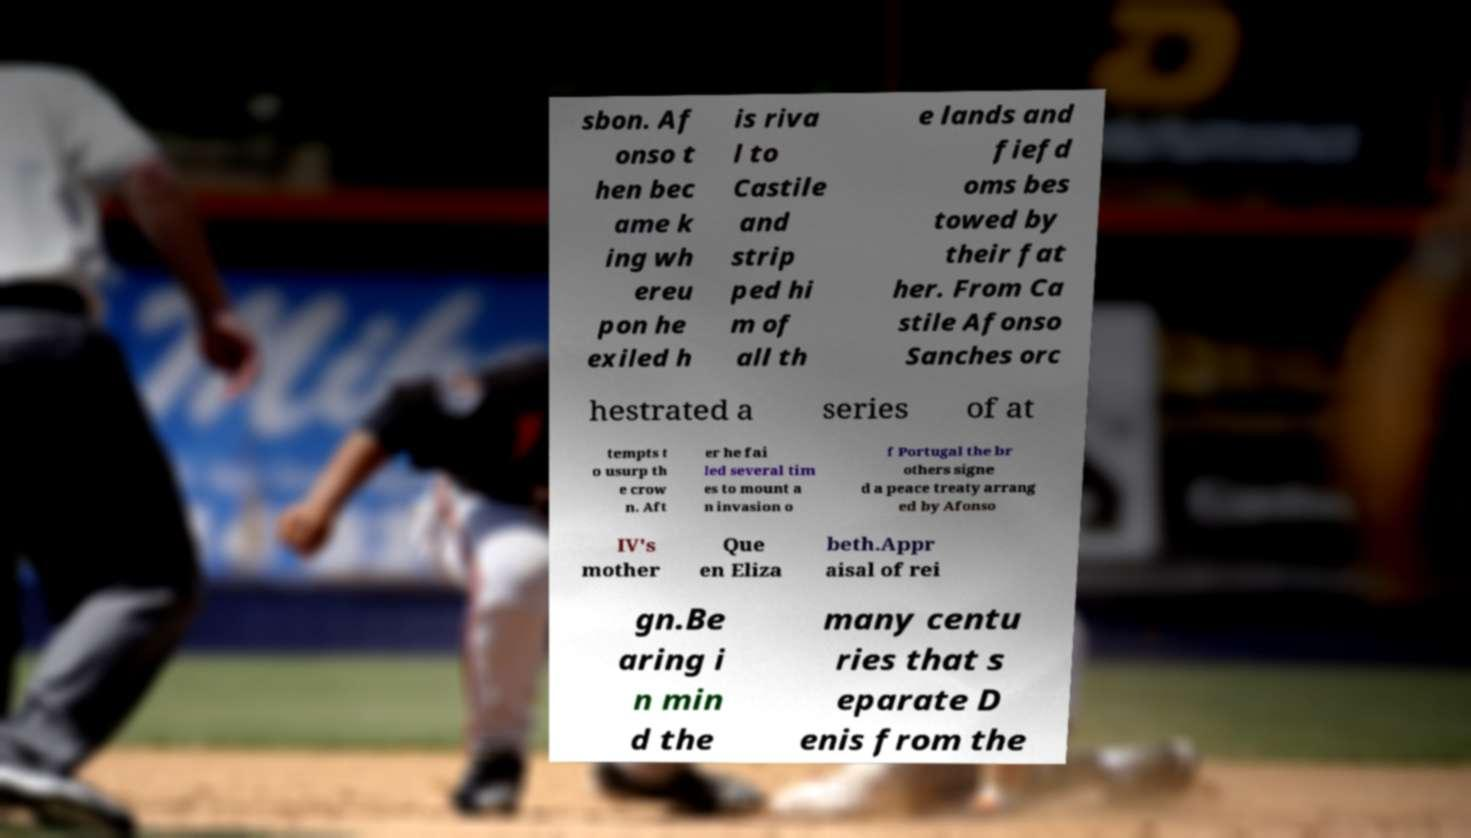Please read and relay the text visible in this image. What does it say? sbon. Af onso t hen bec ame k ing wh ereu pon he exiled h is riva l to Castile and strip ped hi m of all th e lands and fiefd oms bes towed by their fat her. From Ca stile Afonso Sanches orc hestrated a series of at tempts t o usurp th e crow n. Aft er he fai led several tim es to mount a n invasion o f Portugal the br others signe d a peace treaty arrang ed by Afonso IV's mother Que en Eliza beth.Appr aisal of rei gn.Be aring i n min d the many centu ries that s eparate D enis from the 